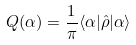Convert formula to latex. <formula><loc_0><loc_0><loc_500><loc_500>Q ( \alpha ) = \frac { 1 } { \pi } \langle \alpha | \hat { \rho } | \alpha \rangle</formula> 